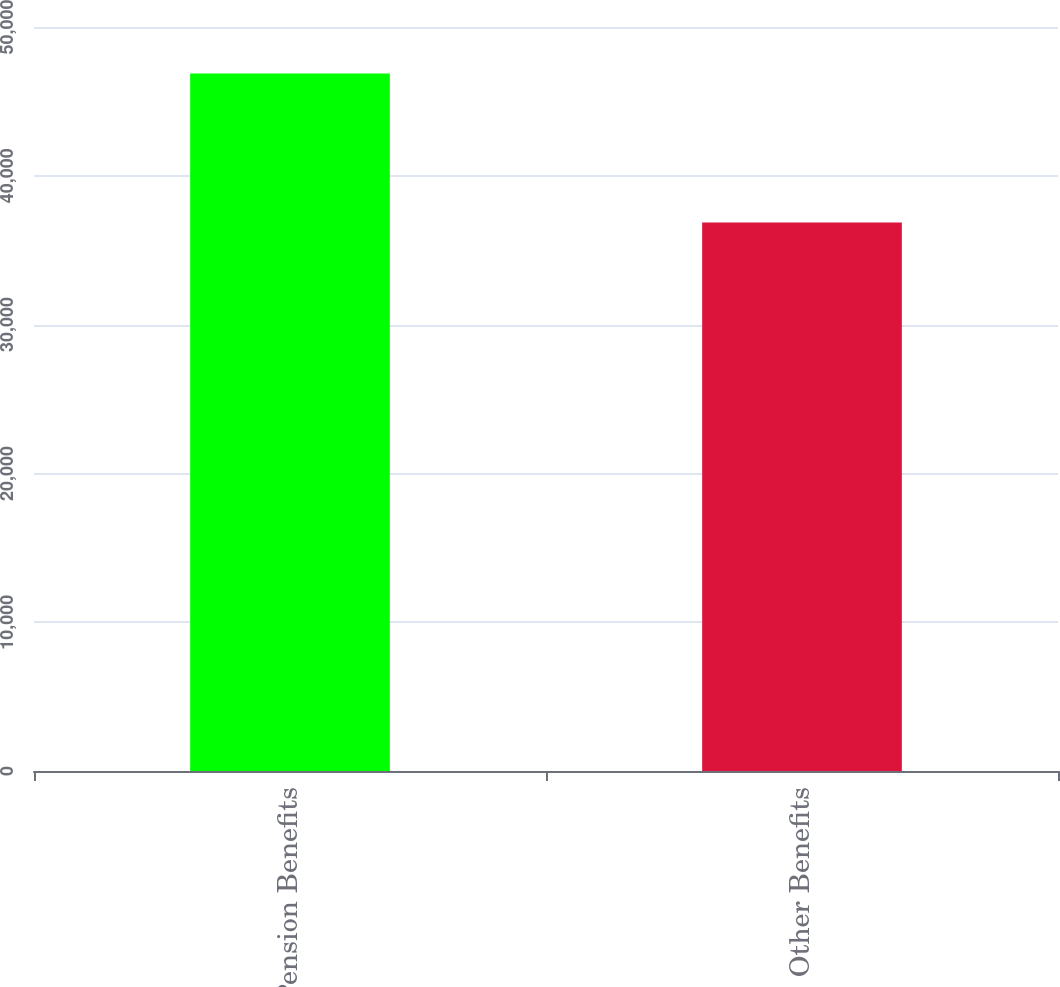Convert chart to OTSL. <chart><loc_0><loc_0><loc_500><loc_500><bar_chart><fcel>Pension Benefits<fcel>Other Benefits<nl><fcel>46877<fcel>36861<nl></chart> 